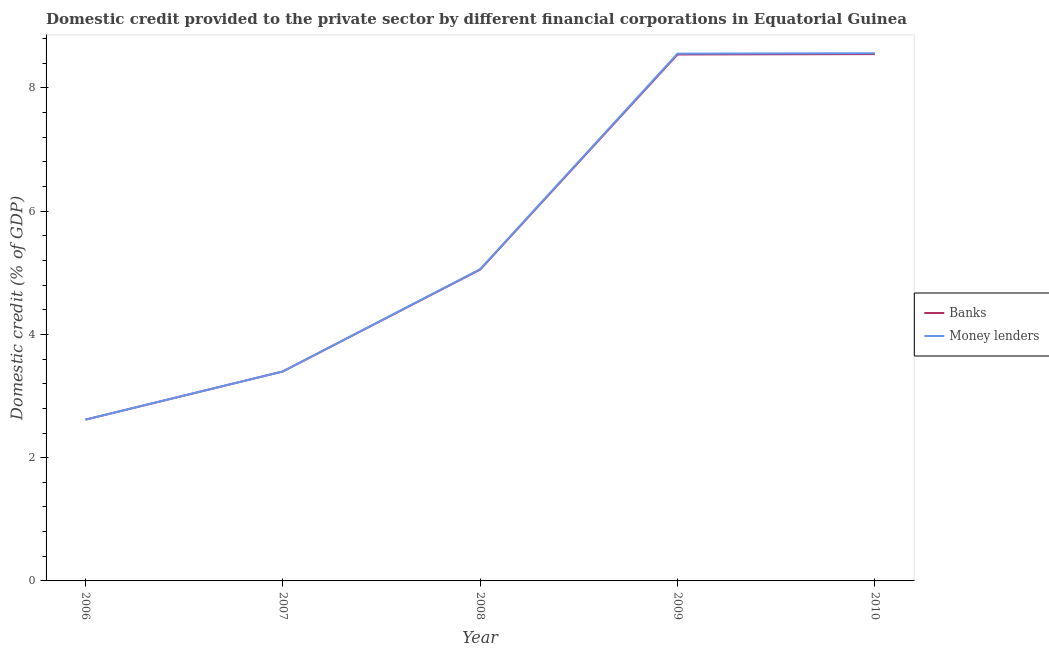How many different coloured lines are there?
Keep it short and to the point. 2. What is the domestic credit provided by banks in 2008?
Make the answer very short. 5.05. Across all years, what is the maximum domestic credit provided by banks?
Your answer should be very brief. 8.55. Across all years, what is the minimum domestic credit provided by banks?
Ensure brevity in your answer.  2.62. What is the total domestic credit provided by banks in the graph?
Your answer should be compact. 28.16. What is the difference between the domestic credit provided by banks in 2006 and that in 2008?
Ensure brevity in your answer.  -2.44. What is the difference between the domestic credit provided by banks in 2006 and the domestic credit provided by money lenders in 2008?
Provide a succinct answer. -2.44. What is the average domestic credit provided by money lenders per year?
Your answer should be compact. 5.64. In the year 2008, what is the difference between the domestic credit provided by money lenders and domestic credit provided by banks?
Keep it short and to the point. 0.01. What is the ratio of the domestic credit provided by banks in 2007 to that in 2009?
Provide a succinct answer. 0.4. Is the domestic credit provided by banks in 2008 less than that in 2010?
Ensure brevity in your answer.  Yes. What is the difference between the highest and the second highest domestic credit provided by banks?
Your answer should be compact. 0.01. What is the difference between the highest and the lowest domestic credit provided by banks?
Provide a succinct answer. 5.93. In how many years, is the domestic credit provided by money lenders greater than the average domestic credit provided by money lenders taken over all years?
Keep it short and to the point. 2. Is the sum of the domestic credit provided by banks in 2006 and 2007 greater than the maximum domestic credit provided by money lenders across all years?
Provide a succinct answer. No. Is the domestic credit provided by money lenders strictly less than the domestic credit provided by banks over the years?
Your response must be concise. No. How many lines are there?
Offer a terse response. 2. How many years are there in the graph?
Provide a succinct answer. 5. What is the difference between two consecutive major ticks on the Y-axis?
Provide a short and direct response. 2. Does the graph contain grids?
Provide a short and direct response. No. How many legend labels are there?
Provide a succinct answer. 2. What is the title of the graph?
Make the answer very short. Domestic credit provided to the private sector by different financial corporations in Equatorial Guinea. Does "Males" appear as one of the legend labels in the graph?
Offer a very short reply. No. What is the label or title of the X-axis?
Your answer should be compact. Year. What is the label or title of the Y-axis?
Your answer should be compact. Domestic credit (% of GDP). What is the Domestic credit (% of GDP) in Banks in 2006?
Keep it short and to the point. 2.62. What is the Domestic credit (% of GDP) of Money lenders in 2006?
Your answer should be very brief. 2.62. What is the Domestic credit (% of GDP) of Banks in 2007?
Give a very brief answer. 3.4. What is the Domestic credit (% of GDP) in Money lenders in 2007?
Ensure brevity in your answer.  3.4. What is the Domestic credit (% of GDP) in Banks in 2008?
Your answer should be compact. 5.05. What is the Domestic credit (% of GDP) of Money lenders in 2008?
Give a very brief answer. 5.06. What is the Domestic credit (% of GDP) of Banks in 2009?
Offer a terse response. 8.54. What is the Domestic credit (% of GDP) in Money lenders in 2009?
Make the answer very short. 8.56. What is the Domestic credit (% of GDP) in Banks in 2010?
Give a very brief answer. 8.55. What is the Domestic credit (% of GDP) of Money lenders in 2010?
Keep it short and to the point. 8.56. Across all years, what is the maximum Domestic credit (% of GDP) of Banks?
Ensure brevity in your answer.  8.55. Across all years, what is the maximum Domestic credit (% of GDP) of Money lenders?
Ensure brevity in your answer.  8.56. Across all years, what is the minimum Domestic credit (% of GDP) in Banks?
Give a very brief answer. 2.62. Across all years, what is the minimum Domestic credit (% of GDP) in Money lenders?
Keep it short and to the point. 2.62. What is the total Domestic credit (% of GDP) in Banks in the graph?
Offer a very short reply. 28.16. What is the total Domestic credit (% of GDP) of Money lenders in the graph?
Offer a terse response. 28.2. What is the difference between the Domestic credit (% of GDP) in Banks in 2006 and that in 2007?
Give a very brief answer. -0.78. What is the difference between the Domestic credit (% of GDP) of Money lenders in 2006 and that in 2007?
Provide a short and direct response. -0.78. What is the difference between the Domestic credit (% of GDP) in Banks in 2006 and that in 2008?
Provide a short and direct response. -2.44. What is the difference between the Domestic credit (% of GDP) in Money lenders in 2006 and that in 2008?
Provide a succinct answer. -2.44. What is the difference between the Domestic credit (% of GDP) of Banks in 2006 and that in 2009?
Provide a short and direct response. -5.93. What is the difference between the Domestic credit (% of GDP) in Money lenders in 2006 and that in 2009?
Keep it short and to the point. -5.94. What is the difference between the Domestic credit (% of GDP) in Banks in 2006 and that in 2010?
Keep it short and to the point. -5.93. What is the difference between the Domestic credit (% of GDP) in Money lenders in 2006 and that in 2010?
Provide a short and direct response. -5.95. What is the difference between the Domestic credit (% of GDP) of Banks in 2007 and that in 2008?
Give a very brief answer. -1.65. What is the difference between the Domestic credit (% of GDP) in Money lenders in 2007 and that in 2008?
Your response must be concise. -1.66. What is the difference between the Domestic credit (% of GDP) in Banks in 2007 and that in 2009?
Keep it short and to the point. -5.14. What is the difference between the Domestic credit (% of GDP) of Money lenders in 2007 and that in 2009?
Provide a succinct answer. -5.16. What is the difference between the Domestic credit (% of GDP) of Banks in 2007 and that in 2010?
Offer a terse response. -5.15. What is the difference between the Domestic credit (% of GDP) in Money lenders in 2007 and that in 2010?
Provide a short and direct response. -5.17. What is the difference between the Domestic credit (% of GDP) in Banks in 2008 and that in 2009?
Keep it short and to the point. -3.49. What is the difference between the Domestic credit (% of GDP) of Money lenders in 2008 and that in 2009?
Your answer should be very brief. -3.5. What is the difference between the Domestic credit (% of GDP) of Banks in 2008 and that in 2010?
Your answer should be very brief. -3.5. What is the difference between the Domestic credit (% of GDP) of Money lenders in 2008 and that in 2010?
Keep it short and to the point. -3.51. What is the difference between the Domestic credit (% of GDP) in Banks in 2009 and that in 2010?
Give a very brief answer. -0.01. What is the difference between the Domestic credit (% of GDP) in Money lenders in 2009 and that in 2010?
Give a very brief answer. -0.01. What is the difference between the Domestic credit (% of GDP) of Banks in 2006 and the Domestic credit (% of GDP) of Money lenders in 2007?
Offer a terse response. -0.78. What is the difference between the Domestic credit (% of GDP) in Banks in 2006 and the Domestic credit (% of GDP) in Money lenders in 2008?
Provide a short and direct response. -2.44. What is the difference between the Domestic credit (% of GDP) of Banks in 2006 and the Domestic credit (% of GDP) of Money lenders in 2009?
Ensure brevity in your answer.  -5.94. What is the difference between the Domestic credit (% of GDP) of Banks in 2006 and the Domestic credit (% of GDP) of Money lenders in 2010?
Make the answer very short. -5.95. What is the difference between the Domestic credit (% of GDP) of Banks in 2007 and the Domestic credit (% of GDP) of Money lenders in 2008?
Make the answer very short. -1.66. What is the difference between the Domestic credit (% of GDP) in Banks in 2007 and the Domestic credit (% of GDP) in Money lenders in 2009?
Your answer should be compact. -5.16. What is the difference between the Domestic credit (% of GDP) in Banks in 2007 and the Domestic credit (% of GDP) in Money lenders in 2010?
Make the answer very short. -5.17. What is the difference between the Domestic credit (% of GDP) in Banks in 2008 and the Domestic credit (% of GDP) in Money lenders in 2009?
Provide a succinct answer. -3.5. What is the difference between the Domestic credit (% of GDP) of Banks in 2008 and the Domestic credit (% of GDP) of Money lenders in 2010?
Make the answer very short. -3.51. What is the difference between the Domestic credit (% of GDP) of Banks in 2009 and the Domestic credit (% of GDP) of Money lenders in 2010?
Provide a short and direct response. -0.02. What is the average Domestic credit (% of GDP) of Banks per year?
Provide a short and direct response. 5.63. What is the average Domestic credit (% of GDP) in Money lenders per year?
Offer a terse response. 5.64. In the year 2006, what is the difference between the Domestic credit (% of GDP) of Banks and Domestic credit (% of GDP) of Money lenders?
Give a very brief answer. 0. In the year 2008, what is the difference between the Domestic credit (% of GDP) of Banks and Domestic credit (% of GDP) of Money lenders?
Provide a succinct answer. -0.01. In the year 2009, what is the difference between the Domestic credit (% of GDP) in Banks and Domestic credit (% of GDP) in Money lenders?
Your answer should be compact. -0.01. In the year 2010, what is the difference between the Domestic credit (% of GDP) of Banks and Domestic credit (% of GDP) of Money lenders?
Provide a succinct answer. -0.01. What is the ratio of the Domestic credit (% of GDP) in Banks in 2006 to that in 2007?
Offer a terse response. 0.77. What is the ratio of the Domestic credit (% of GDP) of Money lenders in 2006 to that in 2007?
Ensure brevity in your answer.  0.77. What is the ratio of the Domestic credit (% of GDP) in Banks in 2006 to that in 2008?
Offer a terse response. 0.52. What is the ratio of the Domestic credit (% of GDP) in Money lenders in 2006 to that in 2008?
Make the answer very short. 0.52. What is the ratio of the Domestic credit (% of GDP) of Banks in 2006 to that in 2009?
Give a very brief answer. 0.31. What is the ratio of the Domestic credit (% of GDP) in Money lenders in 2006 to that in 2009?
Keep it short and to the point. 0.31. What is the ratio of the Domestic credit (% of GDP) of Banks in 2006 to that in 2010?
Ensure brevity in your answer.  0.31. What is the ratio of the Domestic credit (% of GDP) in Money lenders in 2006 to that in 2010?
Offer a terse response. 0.31. What is the ratio of the Domestic credit (% of GDP) in Banks in 2007 to that in 2008?
Provide a succinct answer. 0.67. What is the ratio of the Domestic credit (% of GDP) of Money lenders in 2007 to that in 2008?
Keep it short and to the point. 0.67. What is the ratio of the Domestic credit (% of GDP) in Banks in 2007 to that in 2009?
Ensure brevity in your answer.  0.4. What is the ratio of the Domestic credit (% of GDP) in Money lenders in 2007 to that in 2009?
Keep it short and to the point. 0.4. What is the ratio of the Domestic credit (% of GDP) in Banks in 2007 to that in 2010?
Make the answer very short. 0.4. What is the ratio of the Domestic credit (% of GDP) of Money lenders in 2007 to that in 2010?
Keep it short and to the point. 0.4. What is the ratio of the Domestic credit (% of GDP) in Banks in 2008 to that in 2009?
Provide a short and direct response. 0.59. What is the ratio of the Domestic credit (% of GDP) in Money lenders in 2008 to that in 2009?
Make the answer very short. 0.59. What is the ratio of the Domestic credit (% of GDP) in Banks in 2008 to that in 2010?
Your answer should be very brief. 0.59. What is the ratio of the Domestic credit (% of GDP) in Money lenders in 2008 to that in 2010?
Your response must be concise. 0.59. What is the ratio of the Domestic credit (% of GDP) in Banks in 2009 to that in 2010?
Provide a succinct answer. 1. What is the ratio of the Domestic credit (% of GDP) in Money lenders in 2009 to that in 2010?
Give a very brief answer. 1. What is the difference between the highest and the second highest Domestic credit (% of GDP) of Banks?
Make the answer very short. 0.01. What is the difference between the highest and the second highest Domestic credit (% of GDP) in Money lenders?
Your answer should be very brief. 0.01. What is the difference between the highest and the lowest Domestic credit (% of GDP) in Banks?
Your response must be concise. 5.93. What is the difference between the highest and the lowest Domestic credit (% of GDP) in Money lenders?
Provide a short and direct response. 5.95. 